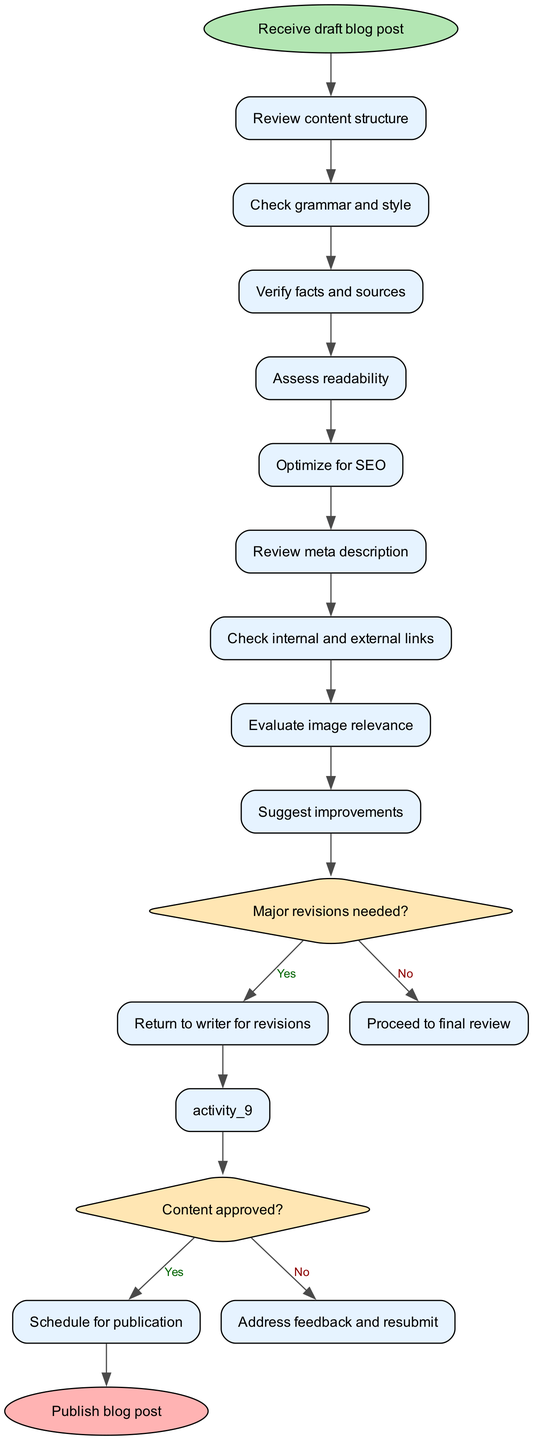What is the initial node of the diagram? The initial node is explicitly stated in the data as "Receive draft blog post." This is the first action taken in the process outlined by the diagram.
Answer: Receive draft blog post How many activities are present in the diagram? The activities array in the data contains nine different activities listed, which indicates that there are nine activities in total.
Answer: 9 What is the last node in the content review process? The final node of the process is provided in the data as "Publish blog post." This is the endpoint of the activity flow represented in the diagram.
Answer: Publish blog post What happens if major revisions are needed? According to the decisions provided, if major revisions are needed, the flow directs to "Return to writer for revisions." This is a clear path outlined in the decision-making steps.
Answer: Return to writer for revisions What is the activity that assesses readability? The specific activity that assesses readability is explicitly listed as one of the activities in the diagram, making it straightforward to identify.
Answer: Assess readability What happens after verifying facts and sources if no major revisions are needed? If no major revisions are needed after verifying facts and sources, the flow continues to the final review. This indicates that the process moves forward without significant changes at this point.
Answer: Proceed to final review How many decision points are in the diagram? The data includes two decisions which indicate that there are two main decision points in the content review process.
Answer: 2 What happens if the content is not approved after the final review? If the content is not approved after the final review, the flow indicates that the next step is to "Address feedback and resubmit," meaning further action is required before publication.
Answer: Address feedback and resubmit What is evaluated regarding images during the review process? The evaluation regarding images is specifically identified as "Evaluate image relevance," which is one of the activities listed in the diagram.
Answer: Evaluate image relevance 